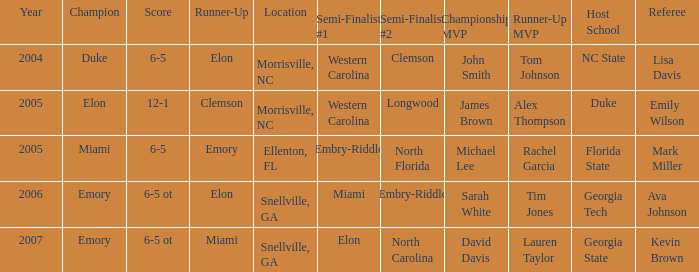Give me the full table as a dictionary. {'header': ['Year', 'Champion', 'Score', 'Runner-Up', 'Location', 'Semi-Finalist #1', 'Semi-Finalist #2', 'Championship MVP', 'Runner-Up MVP', 'Host School', 'Referee'], 'rows': [['2004', 'Duke', '6-5', 'Elon', 'Morrisville, NC', 'Western Carolina', 'Clemson', 'John Smith', 'Tom Johnson', 'NC State', 'Lisa Davis'], ['2005', 'Elon', '12-1', 'Clemson', 'Morrisville, NC', 'Western Carolina', 'Longwood', 'James Brown', 'Alex Thompson', 'Duke', 'Emily Wilson'], ['2005', 'Miami', '6-5', 'Emory', 'Ellenton, FL', 'Embry-Riddle', 'North Florida', 'Michael Lee', 'Rachel Garcia', 'Florida State', 'Mark Miller'], ['2006', 'Emory', '6-5 ot', 'Elon', 'Snellville, GA', 'Miami', 'Embry-Riddle', 'Sarah White', 'Tim Jones', 'Georgia Tech', 'Ava Johnson'], ['2007', 'Emory', '6-5 ot', 'Miami', 'Snellville, GA', 'Elon', 'North Carolina', 'David Davis', 'Lauren Taylor', 'Georgia State', 'Kevin Brown']]} How many teams were listed as runner up in 2005 and there the first semi finalist was Western Carolina? 1.0. 